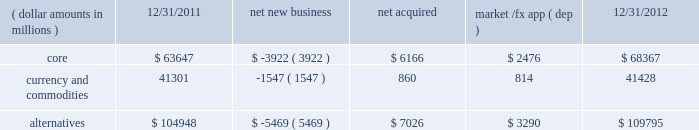Challenging investment environment with $ 15.0 billion , or 95% ( 95 % ) , of net inflows coming from institutional clients , with the remaining $ 0.8 billion , or 5% ( 5 % ) , generated by retail and hnw clients .
Defined contribution plans of institutional clients remained a significant driver of flows .
This client group added $ 13.1 billion of net new business in 2012 .
During the year , americas net inflows of $ 18.5 billion were partially offset by net outflows of $ 2.6 billion collectively from emea and asia-pacific clients .
The company 2019s multi-asset strategies include the following : 2022 asset allocation and balanced products represented 52% ( 52 % ) , or $ 140.2 billion , of multi-asset class aum at year-end , up $ 14.1 billion , with growth in aum driven by net new business of $ 1.6 billion and $ 12.4 billion in market and foreign exchange gains .
These strategies combine equity , fixed income and alternative components for investors seeking a tailored solution relative to a specific benchmark and within a risk budget .
In certain cases , these strategies seek to minimize downside risk through diversification , derivatives strategies and tactical asset allocation decisions .
2022 target date and target risk products ended the year at $ 69.9 billion , up $ 20.8 billion , or 42% ( 42 % ) , since december 31 , 2011 .
Growth in aum was driven by net new business of $ 14.5 billion , a year-over-year organic growth rate of 30% ( 30 % ) .
Institutional investors represented 90% ( 90 % ) of target date and target risk aum , with defined contribution plans accounting for over 80% ( 80 % ) of aum .
The remaining 10% ( 10 % ) of target date and target risk aum consisted of retail client investments .
Flows were driven by defined contribution investments in our lifepath and lifepath retirement income ae offerings , which are qualified investment options under the pension protection act of 2006 .
These products utilize a proprietary asset allocation model that seeks to balance risk and return over an investment horizon based on the investor 2019s expected retirement timing .
2022 fiduciary management services accounted for 22% ( 22 % ) , or $ 57.7 billion , of multi-asset aum at december 31 , 2012 and increased $ 7.7 billion during the year due to market and foreign exchange gains .
These are complex mandates in which pension plan sponsors retain blackrock to assume responsibility for some or all aspects of plan management .
These customized services require strong partnership with the clients 2019 investment staff and trustees in order to tailor investment strategies to meet client-specific risk budgets and return objectives .
Alternatives component changes in alternatives aum ( dollar amounts in millions ) 12/31/2011 net new business acquired market /fx app ( dep ) 12/31/2012 .
Alternatives aum totaled $ 109.8 billion at year-end 2012 , up $ 4.8 billion , or 5% ( 5 % ) , reflecting $ 3.3 billion in portfolio valuation gains and $ 7.0 billion in new assets related to the acquisitions of srpep , which deepened our alternatives footprint in the european and asian markets , and claymore .
Core alternative outflows of $ 3.9 billion were driven almost exclusively by return of capital to clients .
Currency net outflows of $ 5.0 billion were partially offset by net inflows of $ 3.5 billion into ishares commodity funds .
We continued to make significant investments in our alternatives platform as demonstrated by our acquisition of srpep , successful closes on the renewable power initiative and our build out of an alternatives retail platform , which now stands at nearly $ 10.0 billion in aum .
We believe that as alternatives become more conventional and investors adapt their asset allocation strategies to best meet their investment objectives , they will further increase their use of alternative investments to complement core holdings .
Institutional investors represented 69% ( 69 % ) , or $ 75.8 billion , of alternatives aum with retail and hnw investors comprising an additional 9% ( 9 % ) , or $ 9.7 billion , at year-end 2012 .
Ishares commodity products accounted for the remaining $ 24.3 billion , or 22% ( 22 % ) , of aum at year-end .
Alternative clients are geographically diversified with 56% ( 56 % ) , 26% ( 26 % ) , and 18% ( 18 % ) of clients located in the americas , emea and asia-pacific , respectively .
The blackrock alternative investors ( 201cbai 201d ) group coordinates our alternative investment efforts , including .
What is the growth in aum was driven by net new business as a percentage of alternative component changes in alternatives from 12/31/2012? 
Computations: (14.5 / 109.8)
Answer: 0.13206. Challenging investment environment with $ 15.0 billion , or 95% ( 95 % ) , of net inflows coming from institutional clients , with the remaining $ 0.8 billion , or 5% ( 5 % ) , generated by retail and hnw clients .
Defined contribution plans of institutional clients remained a significant driver of flows .
This client group added $ 13.1 billion of net new business in 2012 .
During the year , americas net inflows of $ 18.5 billion were partially offset by net outflows of $ 2.6 billion collectively from emea and asia-pacific clients .
The company 2019s multi-asset strategies include the following : 2022 asset allocation and balanced products represented 52% ( 52 % ) , or $ 140.2 billion , of multi-asset class aum at year-end , up $ 14.1 billion , with growth in aum driven by net new business of $ 1.6 billion and $ 12.4 billion in market and foreign exchange gains .
These strategies combine equity , fixed income and alternative components for investors seeking a tailored solution relative to a specific benchmark and within a risk budget .
In certain cases , these strategies seek to minimize downside risk through diversification , derivatives strategies and tactical asset allocation decisions .
2022 target date and target risk products ended the year at $ 69.9 billion , up $ 20.8 billion , or 42% ( 42 % ) , since december 31 , 2011 .
Growth in aum was driven by net new business of $ 14.5 billion , a year-over-year organic growth rate of 30% ( 30 % ) .
Institutional investors represented 90% ( 90 % ) of target date and target risk aum , with defined contribution plans accounting for over 80% ( 80 % ) of aum .
The remaining 10% ( 10 % ) of target date and target risk aum consisted of retail client investments .
Flows were driven by defined contribution investments in our lifepath and lifepath retirement income ae offerings , which are qualified investment options under the pension protection act of 2006 .
These products utilize a proprietary asset allocation model that seeks to balance risk and return over an investment horizon based on the investor 2019s expected retirement timing .
2022 fiduciary management services accounted for 22% ( 22 % ) , or $ 57.7 billion , of multi-asset aum at december 31 , 2012 and increased $ 7.7 billion during the year due to market and foreign exchange gains .
These are complex mandates in which pension plan sponsors retain blackrock to assume responsibility for some or all aspects of plan management .
These customized services require strong partnership with the clients 2019 investment staff and trustees in order to tailor investment strategies to meet client-specific risk budgets and return objectives .
Alternatives component changes in alternatives aum ( dollar amounts in millions ) 12/31/2011 net new business acquired market /fx app ( dep ) 12/31/2012 .
Alternatives aum totaled $ 109.8 billion at year-end 2012 , up $ 4.8 billion , or 5% ( 5 % ) , reflecting $ 3.3 billion in portfolio valuation gains and $ 7.0 billion in new assets related to the acquisitions of srpep , which deepened our alternatives footprint in the european and asian markets , and claymore .
Core alternative outflows of $ 3.9 billion were driven almost exclusively by return of capital to clients .
Currency net outflows of $ 5.0 billion were partially offset by net inflows of $ 3.5 billion into ishares commodity funds .
We continued to make significant investments in our alternatives platform as demonstrated by our acquisition of srpep , successful closes on the renewable power initiative and our build out of an alternatives retail platform , which now stands at nearly $ 10.0 billion in aum .
We believe that as alternatives become more conventional and investors adapt their asset allocation strategies to best meet their investment objectives , they will further increase their use of alternative investments to complement core holdings .
Institutional investors represented 69% ( 69 % ) , or $ 75.8 billion , of alternatives aum with retail and hnw investors comprising an additional 9% ( 9 % ) , or $ 9.7 billion , at year-end 2012 .
Ishares commodity products accounted for the remaining $ 24.3 billion , or 22% ( 22 % ) , of aum at year-end .
Alternative clients are geographically diversified with 56% ( 56 % ) , 26% ( 26 % ) , and 18% ( 18 % ) of clients located in the americas , emea and asia-pacific , respectively .
The blackrock alternative investors ( 201cbai 201d ) group coordinates our alternative investment efforts , including .
What is the percent change in alternative component changes in alternatives from 12/31/2011 to 12/31/2012? 
Computations: ((109795 - 104948) / 104948)
Answer: 0.04618. 